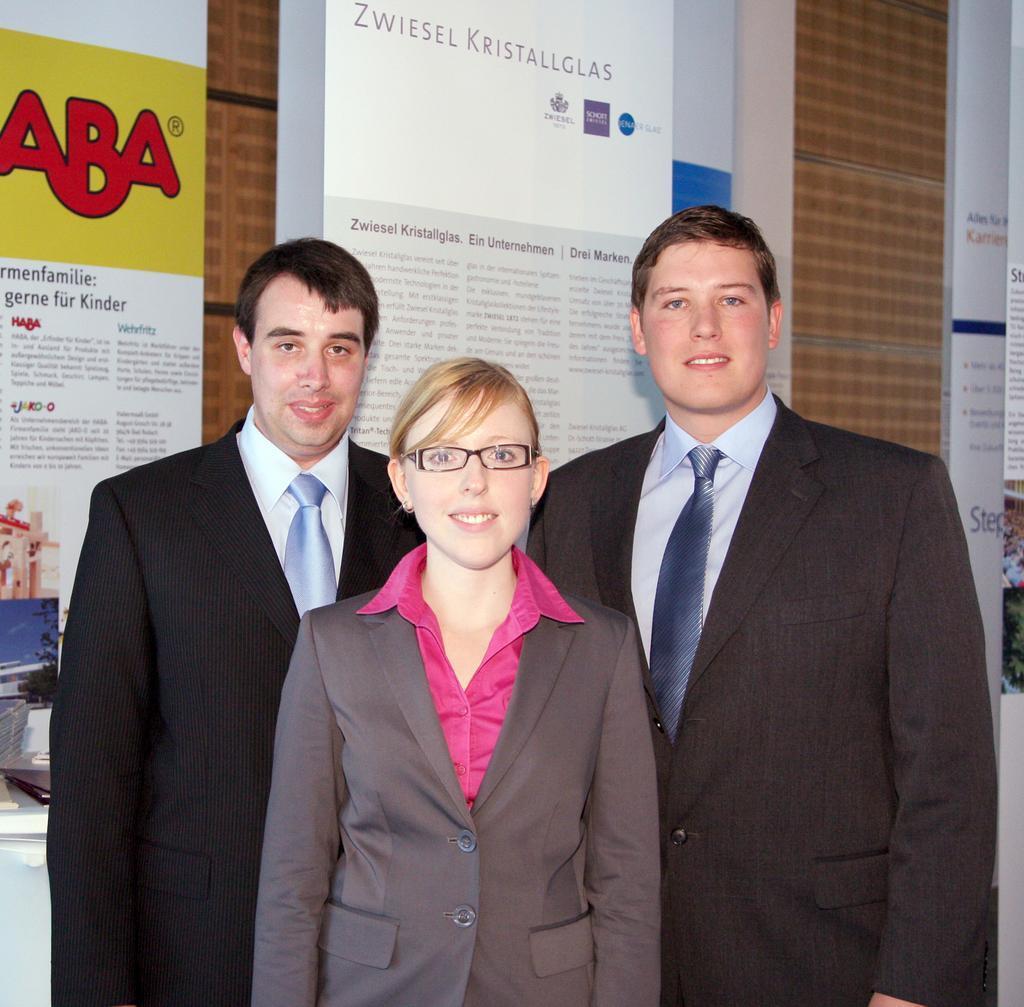Describe this image in one or two sentences. 3 people are standing wearing suit. The person at the center is wearing spectacles and pink shirt. There are posters behind them. 